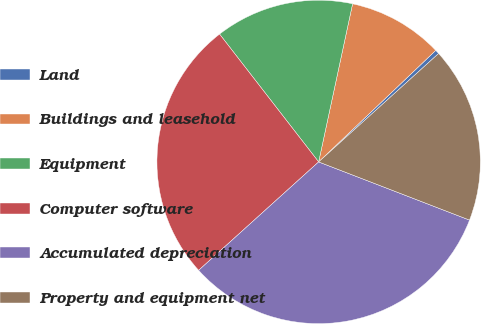Convert chart to OTSL. <chart><loc_0><loc_0><loc_500><loc_500><pie_chart><fcel>Land<fcel>Buildings and leasehold<fcel>Equipment<fcel>Computer software<fcel>Accumulated depreciation<fcel>Property and equipment net<nl><fcel>0.42%<fcel>9.52%<fcel>13.86%<fcel>26.2%<fcel>32.45%<fcel>17.55%<nl></chart> 